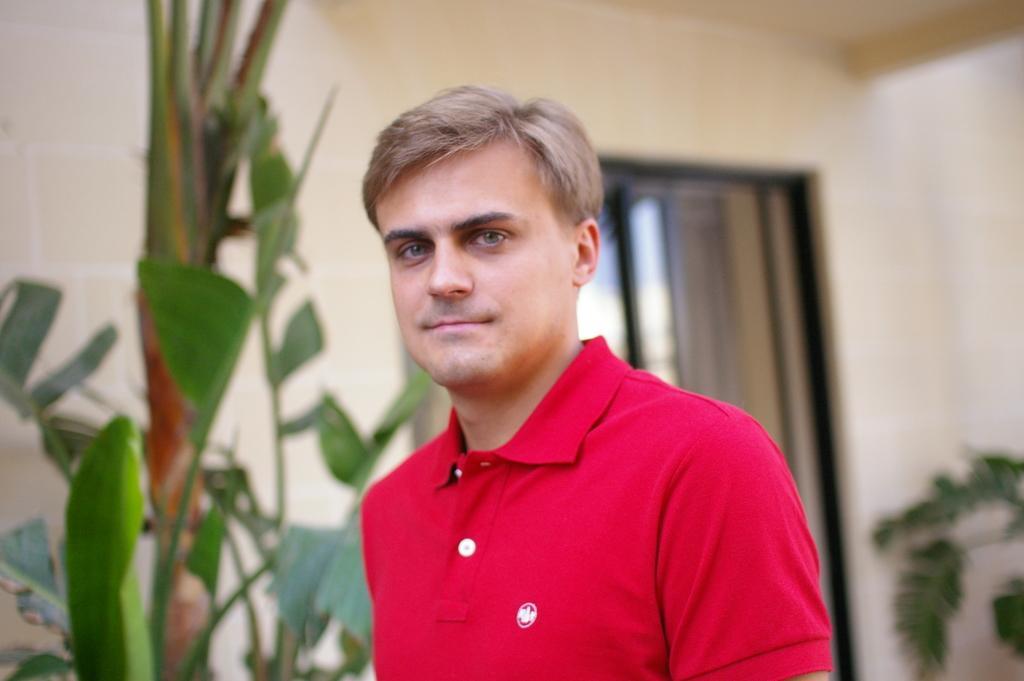Can you describe this image briefly? In this image, I can see the man standing and smiling. He wore a red T-shirt. These look like the plants with the leaves. In the background, I think this is a door. Here is the wall. 